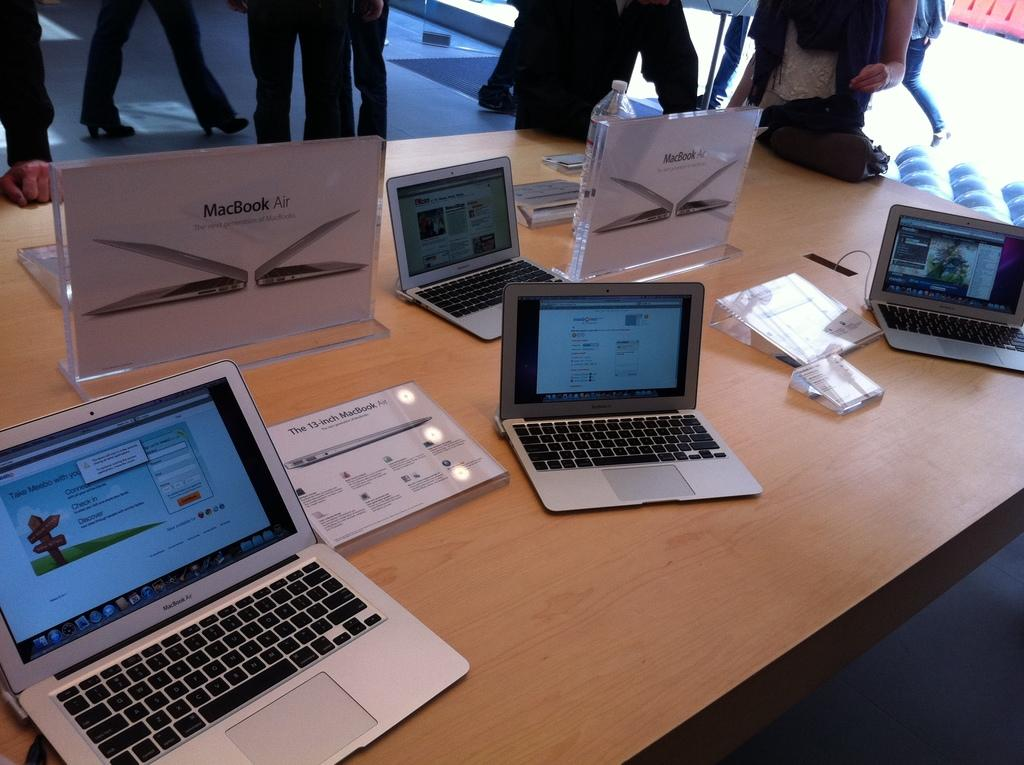<image>
Create a compact narrative representing the image presented. four macbook airs on display, with placards reading specs 